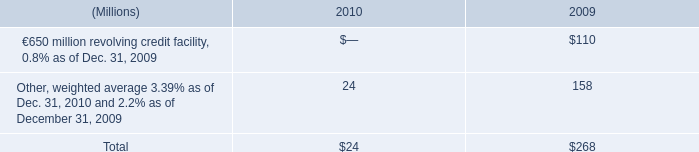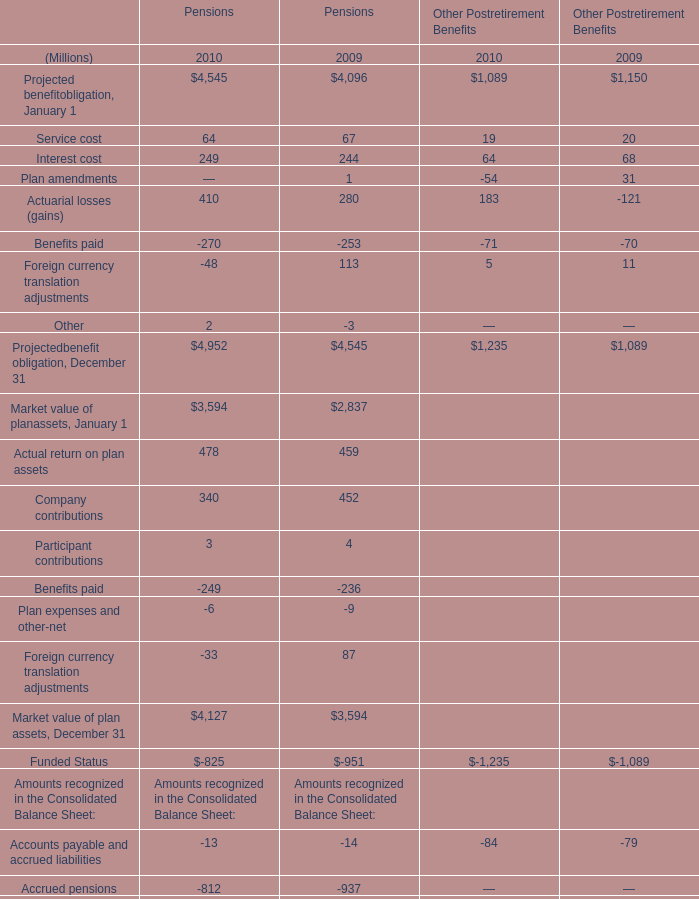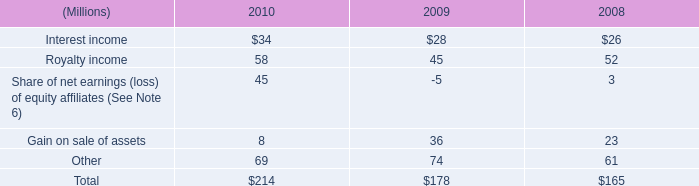Which year is Interest cost for Pensions the most? 
Answer: 2010. 